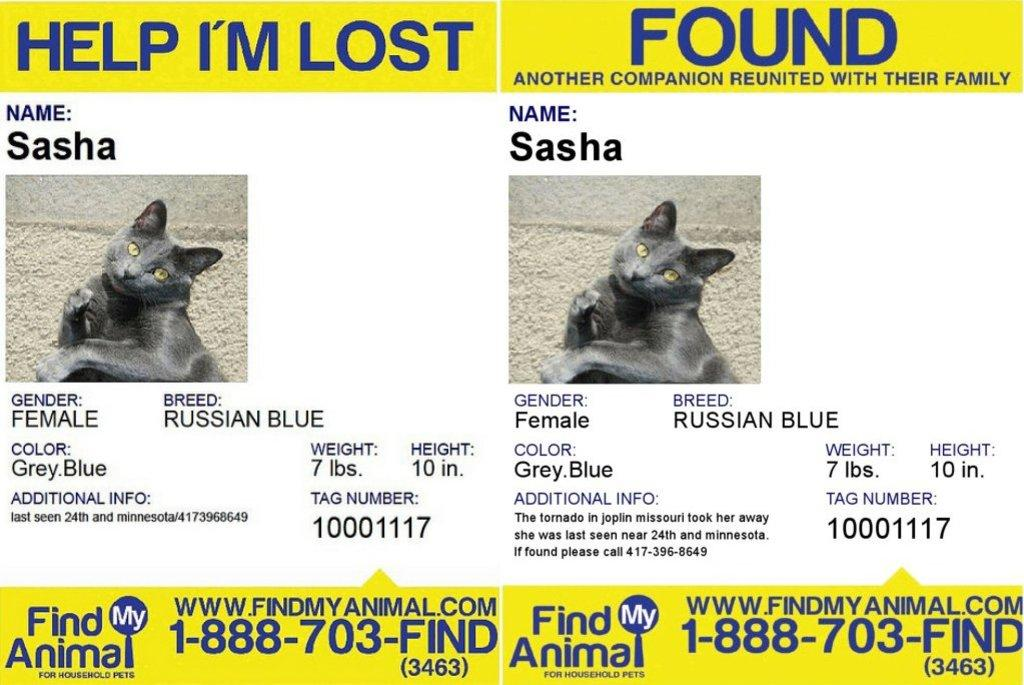What can be seen on the walls in the image? There are posters in the image. Can you describe one of the posters in more detail? One of the posters has a cat picture on it. Are there any words or letters on the posters? Yes, there is text written on one of the posters. Can you see a train passing by in the image? There is no train present in the image. Is there a tiger or a zebra in the image? Neither a tiger nor a zebra is present in the image; the image features posters with a cat picture and text. 